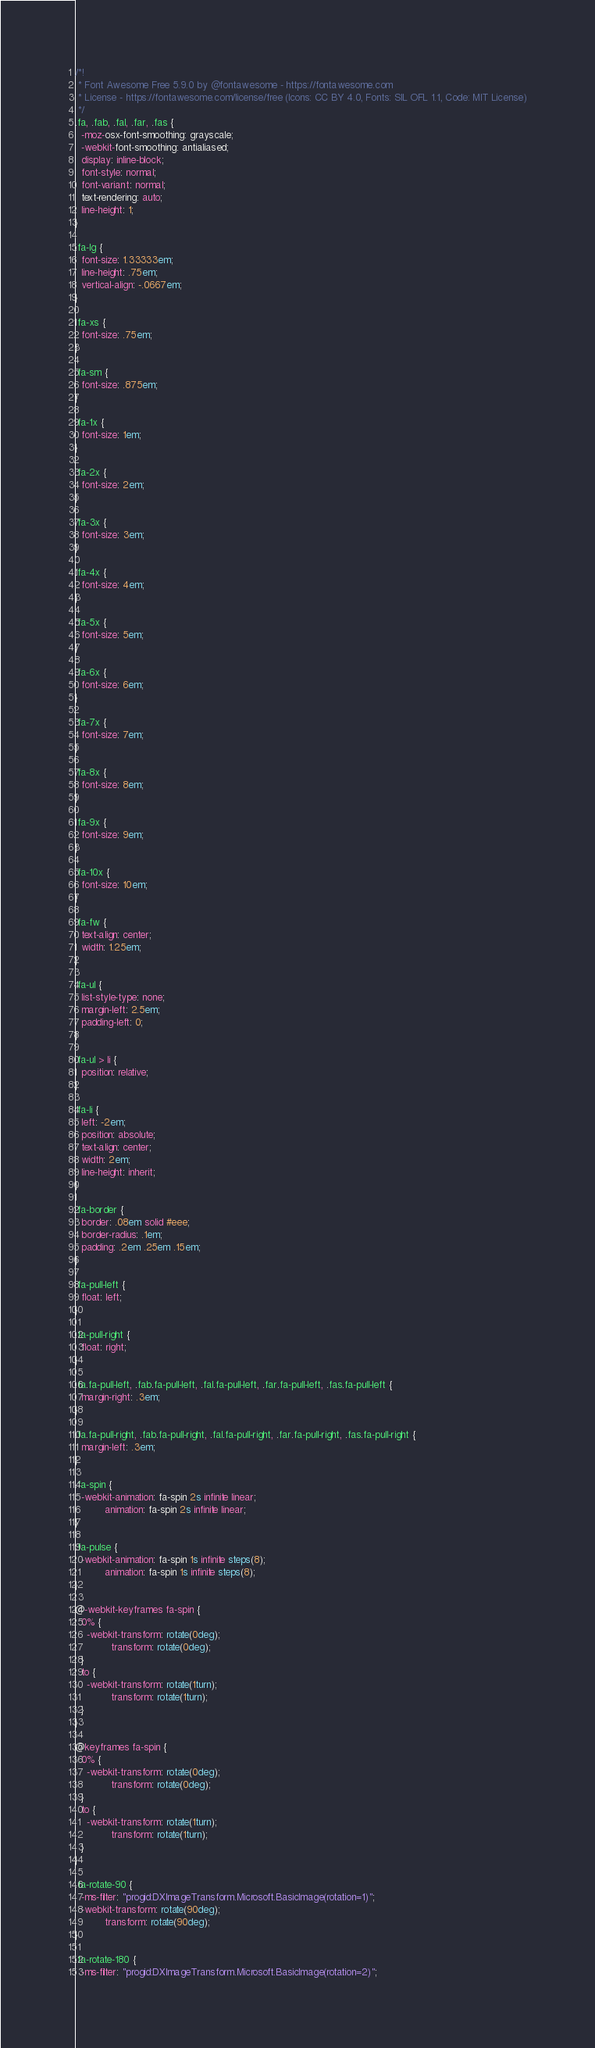<code> <loc_0><loc_0><loc_500><loc_500><_CSS_>/*!
 * Font Awesome Free 5.9.0 by @fontawesome - https://fontawesome.com
 * License - https://fontawesome.com/license/free (Icons: CC BY 4.0, Fonts: SIL OFL 1.1, Code: MIT License)
 */
.fa, .fab, .fal, .far, .fas {
  -moz-osx-font-smoothing: grayscale;
  -webkit-font-smoothing: antialiased;
  display: inline-block;
  font-style: normal;
  font-variant: normal;
  text-rendering: auto;
  line-height: 1;
}

.fa-lg {
  font-size: 1.33333em;
  line-height: .75em;
  vertical-align: -.0667em;
}

.fa-xs {
  font-size: .75em;
}

.fa-sm {
  font-size: .875em;
}

.fa-1x {
  font-size: 1em;
}

.fa-2x {
  font-size: 2em;
}

.fa-3x {
  font-size: 3em;
}

.fa-4x {
  font-size: 4em;
}

.fa-5x {
  font-size: 5em;
}

.fa-6x {
  font-size: 6em;
}

.fa-7x {
  font-size: 7em;
}

.fa-8x {
  font-size: 8em;
}

.fa-9x {
  font-size: 9em;
}

.fa-10x {
  font-size: 10em;
}

.fa-fw {
  text-align: center;
  width: 1.25em;
}

.fa-ul {
  list-style-type: none;
  margin-left: 2.5em;
  padding-left: 0;
}

.fa-ul > li {
  position: relative;
}

.fa-li {
  left: -2em;
  position: absolute;
  text-align: center;
  width: 2em;
  line-height: inherit;
}

.fa-border {
  border: .08em solid #eee;
  border-radius: .1em;
  padding: .2em .25em .15em;
}

.fa-pull-left {
  float: left;
}

.fa-pull-right {
  float: right;
}

.fa.fa-pull-left, .fab.fa-pull-left, .fal.fa-pull-left, .far.fa-pull-left, .fas.fa-pull-left {
  margin-right: .3em;
}

.fa.fa-pull-right, .fab.fa-pull-right, .fal.fa-pull-right, .far.fa-pull-right, .fas.fa-pull-right {
  margin-left: .3em;
}

.fa-spin {
  -webkit-animation: fa-spin 2s infinite linear;
          animation: fa-spin 2s infinite linear;
}

.fa-pulse {
  -webkit-animation: fa-spin 1s infinite steps(8);
          animation: fa-spin 1s infinite steps(8);
}

@-webkit-keyframes fa-spin {
  0% {
    -webkit-transform: rotate(0deg);
            transform: rotate(0deg);
  }
  to {
    -webkit-transform: rotate(1turn);
            transform: rotate(1turn);
  }
}

@keyframes fa-spin {
  0% {
    -webkit-transform: rotate(0deg);
            transform: rotate(0deg);
  }
  to {
    -webkit-transform: rotate(1turn);
            transform: rotate(1turn);
  }
}

.fa-rotate-90 {
  -ms-filter: "progid:DXImageTransform.Microsoft.BasicImage(rotation=1)";
  -webkit-transform: rotate(90deg);
          transform: rotate(90deg);
}

.fa-rotate-180 {
  -ms-filter: "progid:DXImageTransform.Microsoft.BasicImage(rotation=2)";</code> 